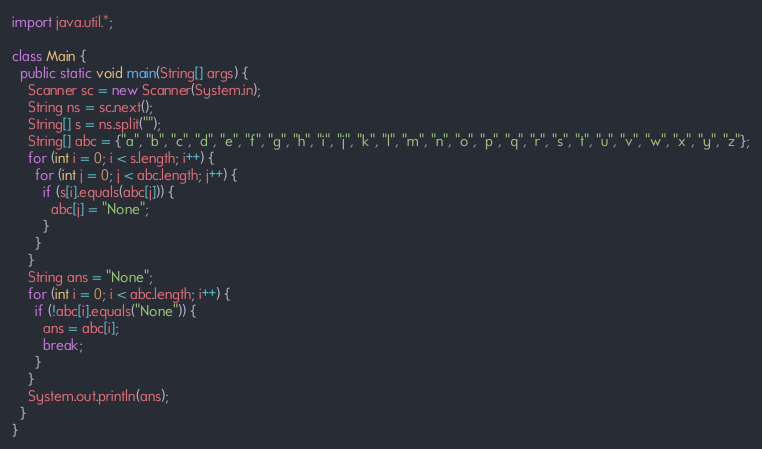<code> <loc_0><loc_0><loc_500><loc_500><_Java_>import java.util.*;

class Main {
  public static void main(String[] args) {
    Scanner sc = new Scanner(System.in);
    String ns = sc.next();
    String[] s = ns.split("");
    String[] abc = {"a", "b", "c", "d", "e", "f", "g", "h", "i", "j", "k", "l", "m", "n", "o", "p", "q", "r", "s", "t", "u", "v", "w", "x", "y", "z"};
    for (int i = 0; i < s.length; i++) {
      for (int j = 0; j < abc.length; j++) {
        if (s[i].equals(abc[j])) {
          abc[j] = "None";
        }
      }
    }
    String ans = "None";
    for (int i = 0; i < abc.length; i++) {
      if (!abc[i].equals("None")) {
        ans = abc[i];
        break;
      }
    }
    System.out.println(ans);
  }
}</code> 